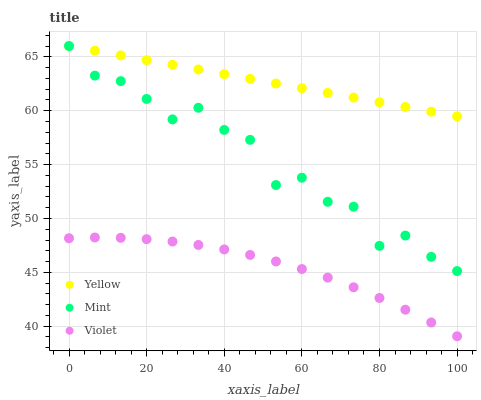Does Violet have the minimum area under the curve?
Answer yes or no. Yes. Does Yellow have the maximum area under the curve?
Answer yes or no. Yes. Does Yellow have the minimum area under the curve?
Answer yes or no. No. Does Violet have the maximum area under the curve?
Answer yes or no. No. Is Yellow the smoothest?
Answer yes or no. Yes. Is Mint the roughest?
Answer yes or no. Yes. Is Violet the smoothest?
Answer yes or no. No. Is Violet the roughest?
Answer yes or no. No. Does Violet have the lowest value?
Answer yes or no. Yes. Does Yellow have the lowest value?
Answer yes or no. No. Does Yellow have the highest value?
Answer yes or no. Yes. Does Violet have the highest value?
Answer yes or no. No. Is Violet less than Mint?
Answer yes or no. Yes. Is Yellow greater than Violet?
Answer yes or no. Yes. Does Yellow intersect Mint?
Answer yes or no. Yes. Is Yellow less than Mint?
Answer yes or no. No. Is Yellow greater than Mint?
Answer yes or no. No. Does Violet intersect Mint?
Answer yes or no. No. 